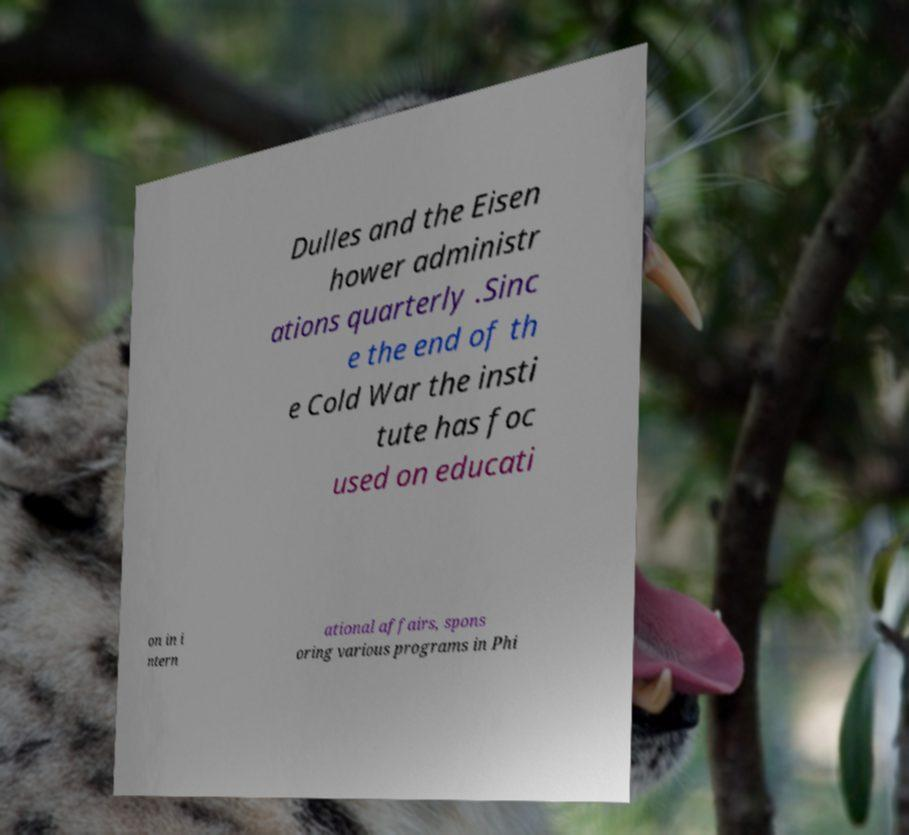I need the written content from this picture converted into text. Can you do that? Dulles and the Eisen hower administr ations quarterly .Sinc e the end of th e Cold War the insti tute has foc used on educati on in i ntern ational affairs, spons oring various programs in Phi 